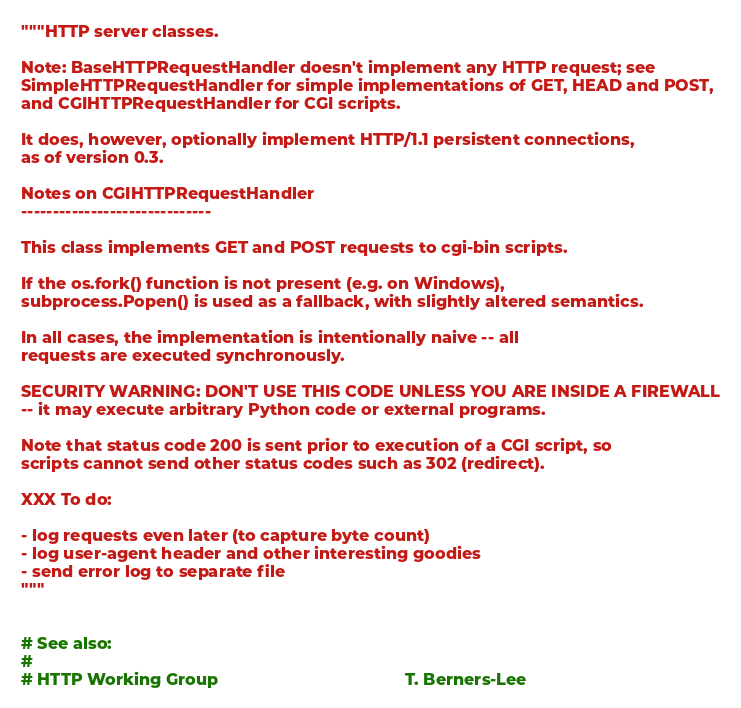<code> <loc_0><loc_0><loc_500><loc_500><_Python_>"""HTTP server classes.

Note: BaseHTTPRequestHandler doesn't implement any HTTP request; see
SimpleHTTPRequestHandler for simple implementations of GET, HEAD and POST,
and CGIHTTPRequestHandler for CGI scripts.

It does, however, optionally implement HTTP/1.1 persistent connections,
as of version 0.3.

Notes on CGIHTTPRequestHandler
------------------------------

This class implements GET and POST requests to cgi-bin scripts.

If the os.fork() function is not present (e.g. on Windows),
subprocess.Popen() is used as a fallback, with slightly altered semantics.

In all cases, the implementation is intentionally naive -- all
requests are executed synchronously.

SECURITY WARNING: DON'T USE THIS CODE UNLESS YOU ARE INSIDE A FIREWALL
-- it may execute arbitrary Python code or external programs.

Note that status code 200 is sent prior to execution of a CGI script, so
scripts cannot send other status codes such as 302 (redirect).

XXX To do:

- log requests even later (to capture byte count)
- log user-agent header and other interesting goodies
- send error log to separate file
"""


# See also:
#
# HTTP Working Group                                        T. Berners-Lee</code> 